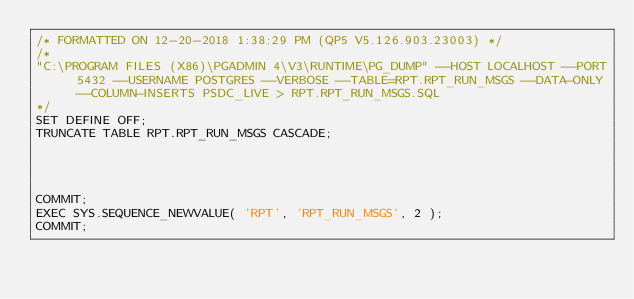<code> <loc_0><loc_0><loc_500><loc_500><_SQL_>/* FORMATTED ON 12-20-2018 1:38:29 PM (QP5 V5.126.903.23003) */
/*
"C:\PROGRAM FILES (X86)\PGADMIN 4\V3\RUNTIME\PG_DUMP" --HOST LOCALHOST --PORT 5432 --USERNAME POSTGRES --VERBOSE --TABLE=RPT.RPT_RUN_MSGS --DATA-ONLY --COLUMN-INSERTS PSDC_LIVE > RPT.RPT_RUN_MSGS.SQL
*/
SET DEFINE OFF;
TRUNCATE TABLE RPT.RPT_RUN_MSGS CASCADE;




COMMIT;
EXEC SYS.SEQUENCE_NEWVALUE( 'RPT', 'RPT_RUN_MSGS', 2 );
COMMIT;

</code> 